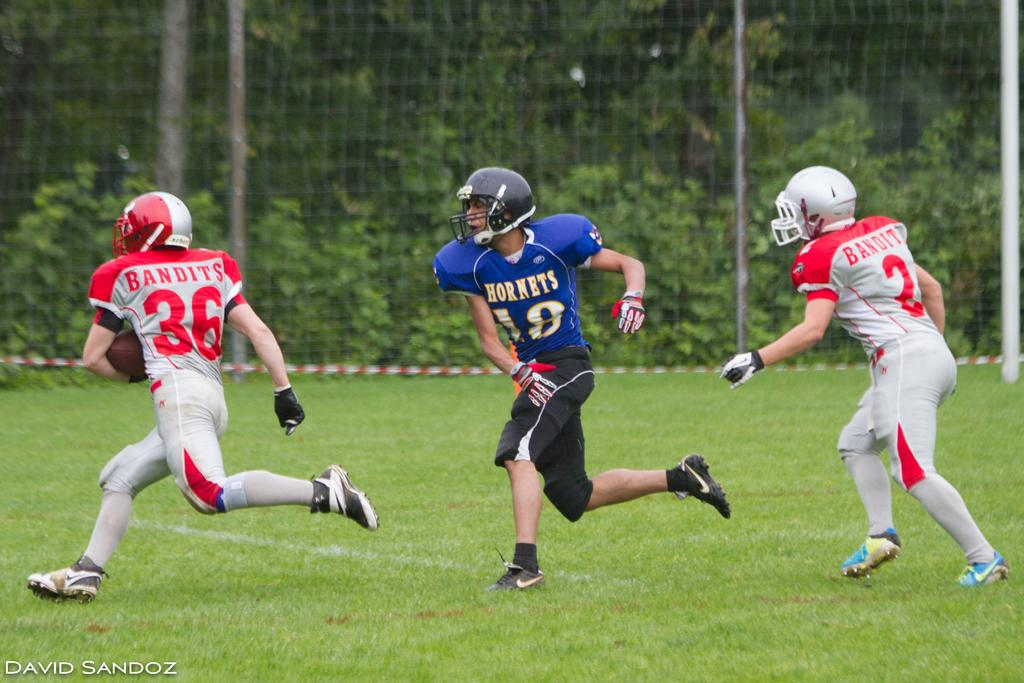How many sports people are in the image? There are three sports people in the image. What are the sports people wearing? The sports people are wearing jerseys and helmets. Where are the sports people located? The sports people are on a field. What is present beside the sports people? There is a net beside the sports people. Can you see any deer joining the sports people in the image? There are no deer present in the image. What type of exchange is happening between the sports people in the image? The image does not depict any exchange between the sports people; it only shows them on the field with a net beside them. 